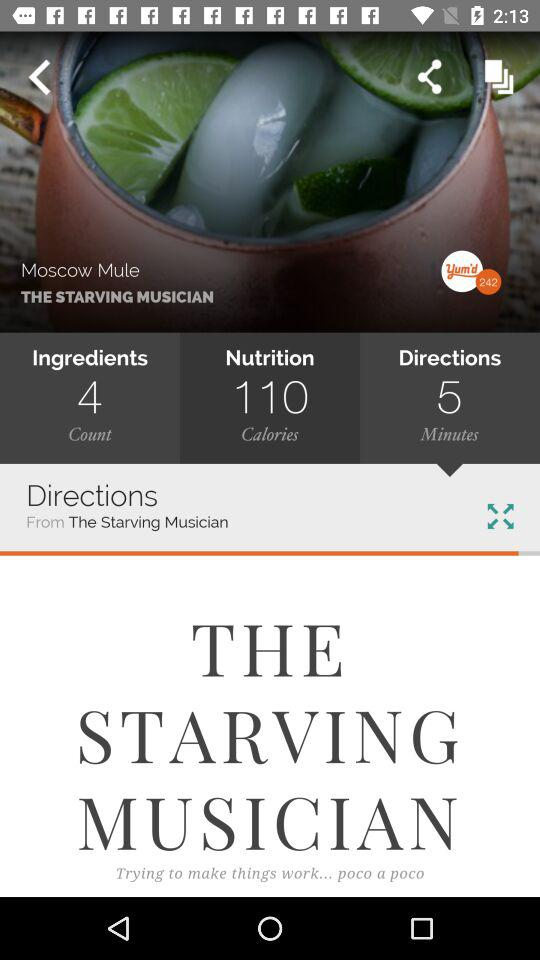How much time will it take to make the dish? It will take 5 minutes to make the dish. 